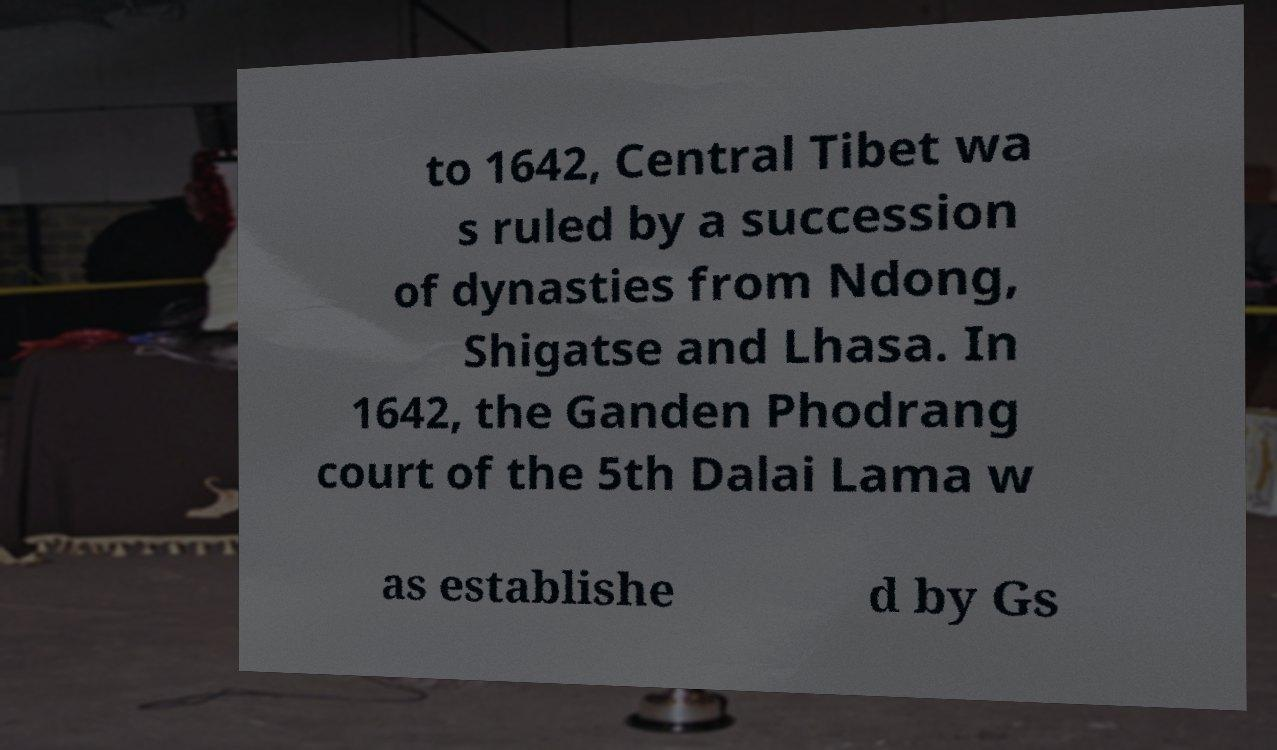Can you read and provide the text displayed in the image?This photo seems to have some interesting text. Can you extract and type it out for me? to 1642, Central Tibet wa s ruled by a succession of dynasties from Ndong, Shigatse and Lhasa. In 1642, the Ganden Phodrang court of the 5th Dalai Lama w as establishe d by Gs 